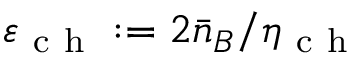Convert formula to latex. <formula><loc_0><loc_0><loc_500><loc_500>\varepsilon _ { c h } \colon = 2 \bar { n } _ { B } / \eta _ { c h }</formula> 